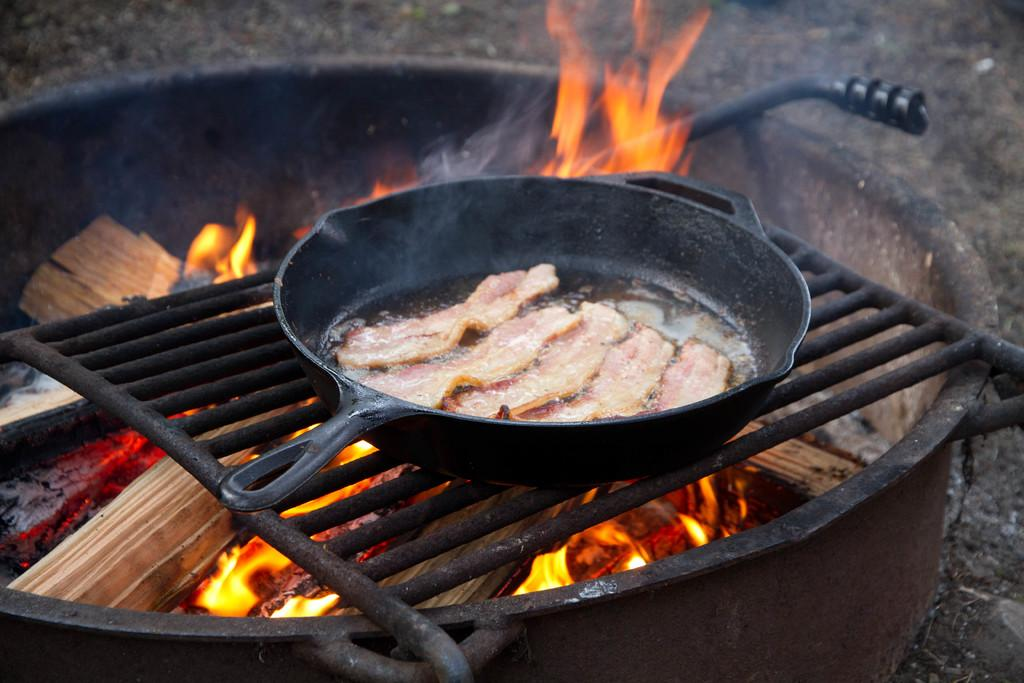What is the main object in the image that contains fire? There is a vessel with fire in the image. What is the purpose of the vessel with fire? The vessel with fire is likely used for cooking or grilling. What can be seen near the vessel with fire? There is a grill in the image. What type of food is being prepared on the grill? There are food items in a bowl on the grill. What type of print can be seen on the food items in the image? There is no print visible on the food items in the image. What type of drink is being served with the food in the image? There is no drink visible in the image. 